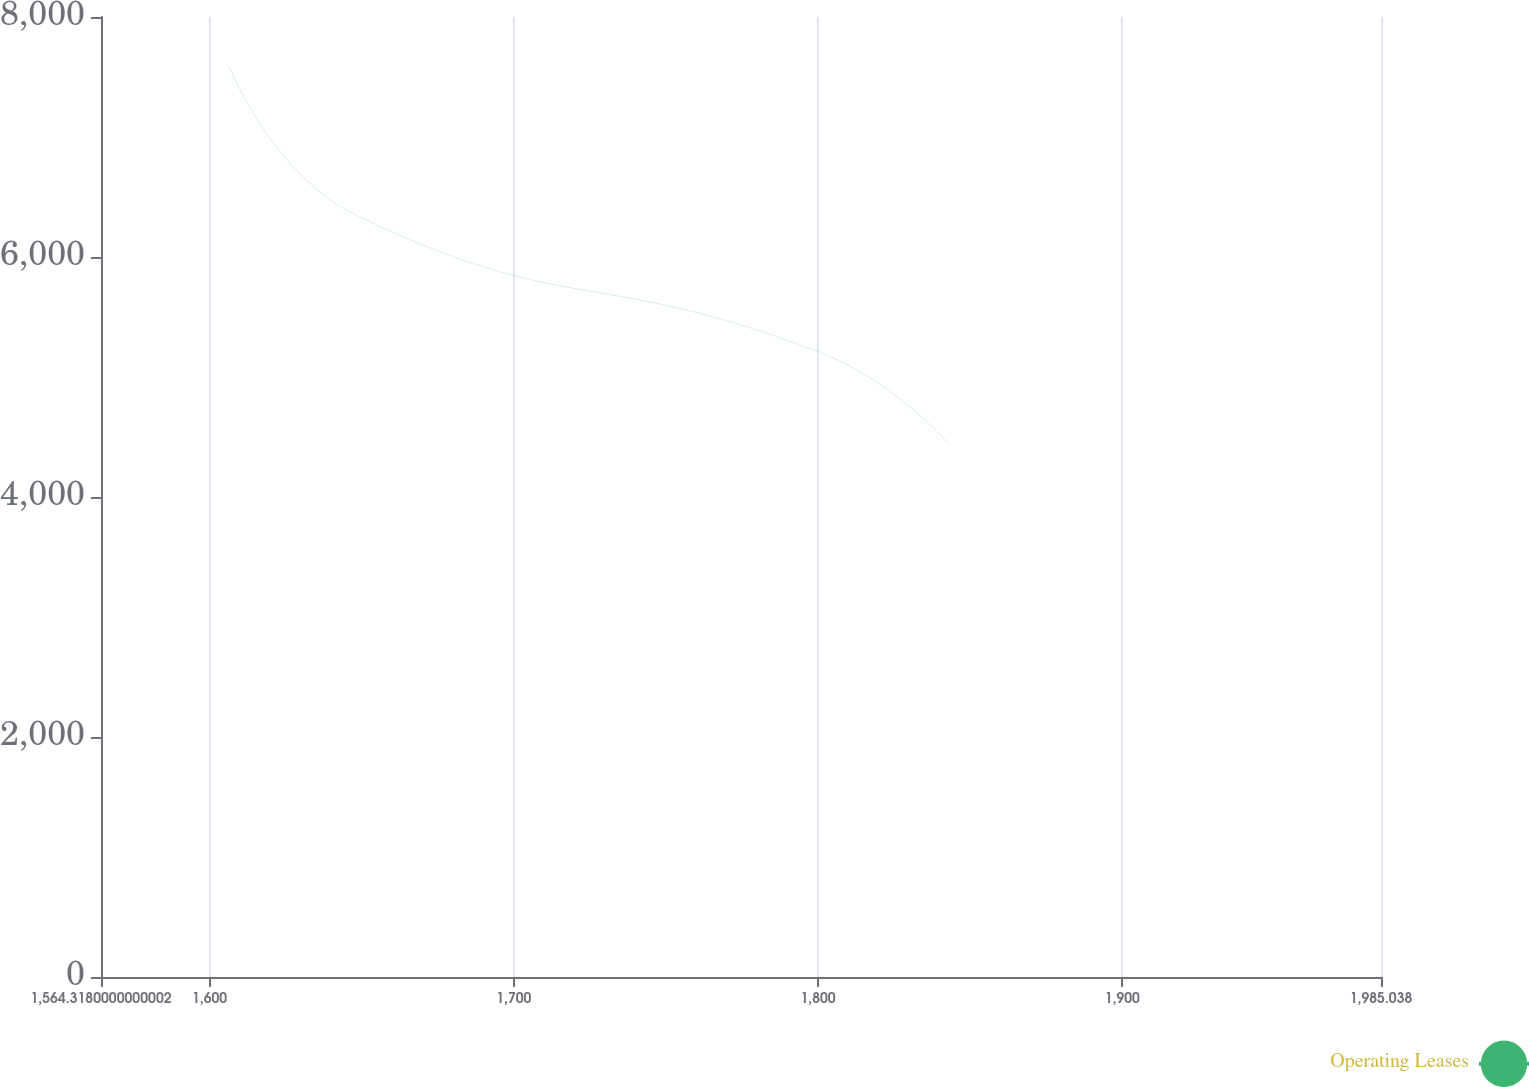Convert chart to OTSL. <chart><loc_0><loc_0><loc_500><loc_500><line_chart><ecel><fcel>Operating Leases<nl><fcel>1606.39<fcel>7593.5<nl><fcel>1648.46<fcel>6344.81<nl><fcel>1801.19<fcel>5199.36<nl><fcel>1843.26<fcel>4435.12<nl><fcel>2027.11<fcel>4763.12<nl></chart> 